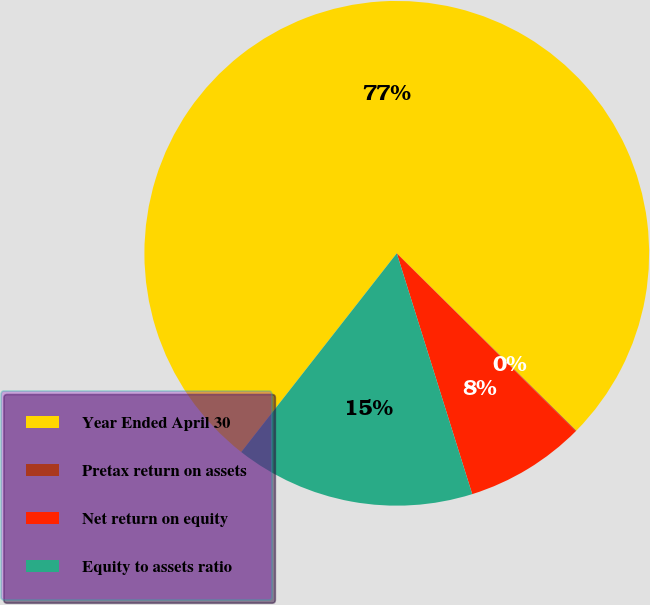Convert chart to OTSL. <chart><loc_0><loc_0><loc_500><loc_500><pie_chart><fcel>Year Ended April 30<fcel>Pretax return on assets<fcel>Net return on equity<fcel>Equity to assets ratio<nl><fcel>76.84%<fcel>0.04%<fcel>7.72%<fcel>15.4%<nl></chart> 